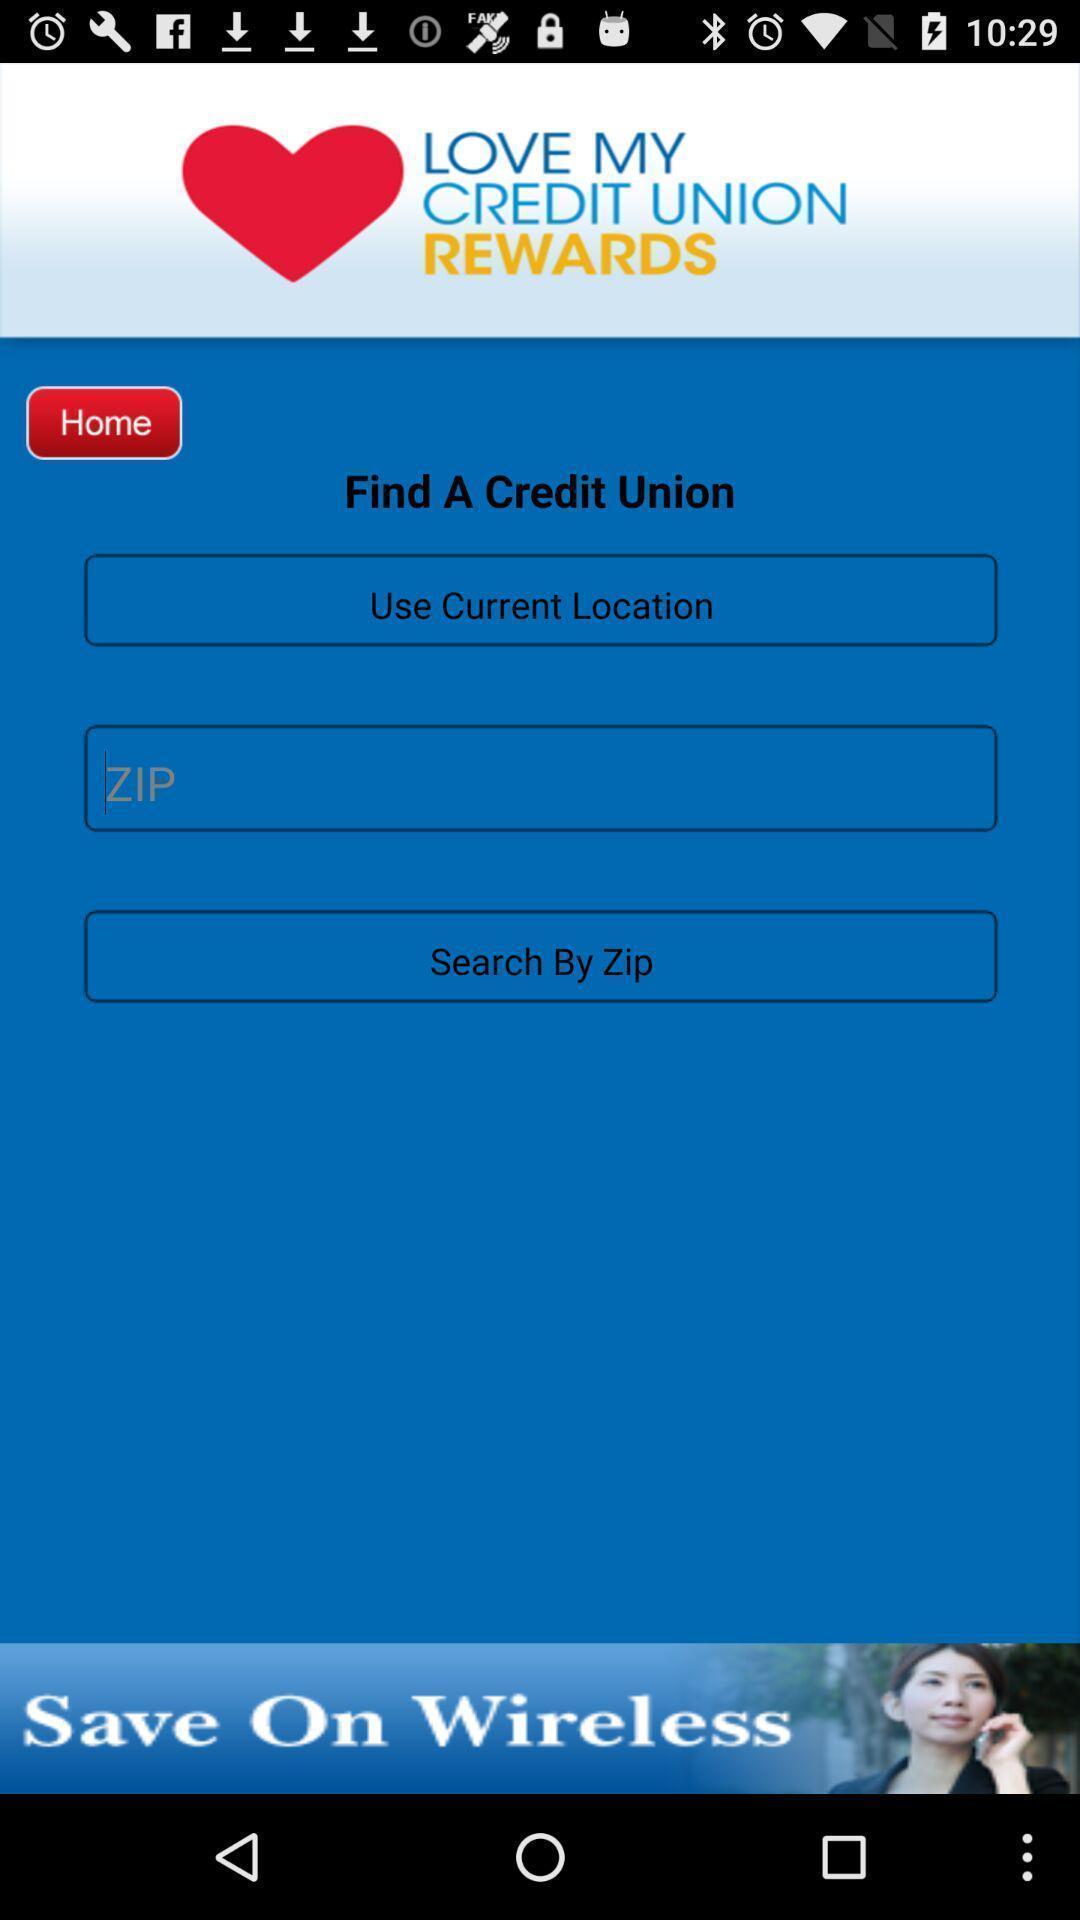Describe this image in words. Welcome page for dating app. 